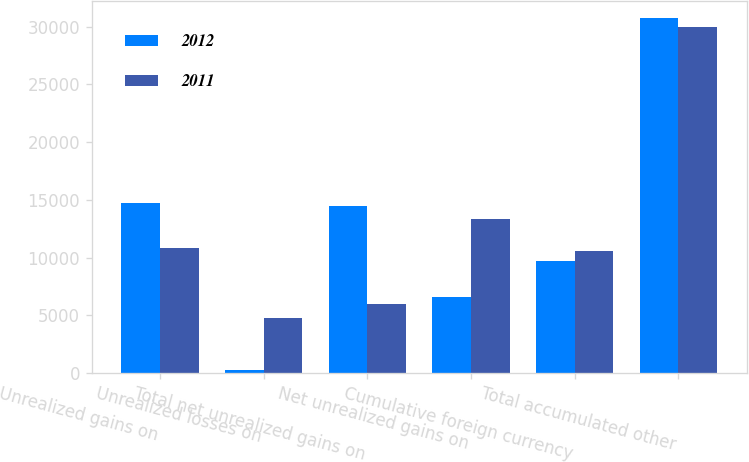<chart> <loc_0><loc_0><loc_500><loc_500><stacked_bar_chart><ecel><fcel>Unrealized gains on<fcel>Unrealized losses on<fcel>Total net unrealized gains on<fcel>Net unrealized gains on<fcel>Cumulative foreign currency<fcel>Total accumulated other<nl><fcel>2012<fcel>14698<fcel>259<fcel>14439<fcel>6604<fcel>9669<fcel>30712<nl><fcel>2011<fcel>10810<fcel>4794<fcel>6016<fcel>13354<fcel>10580<fcel>29950<nl></chart> 